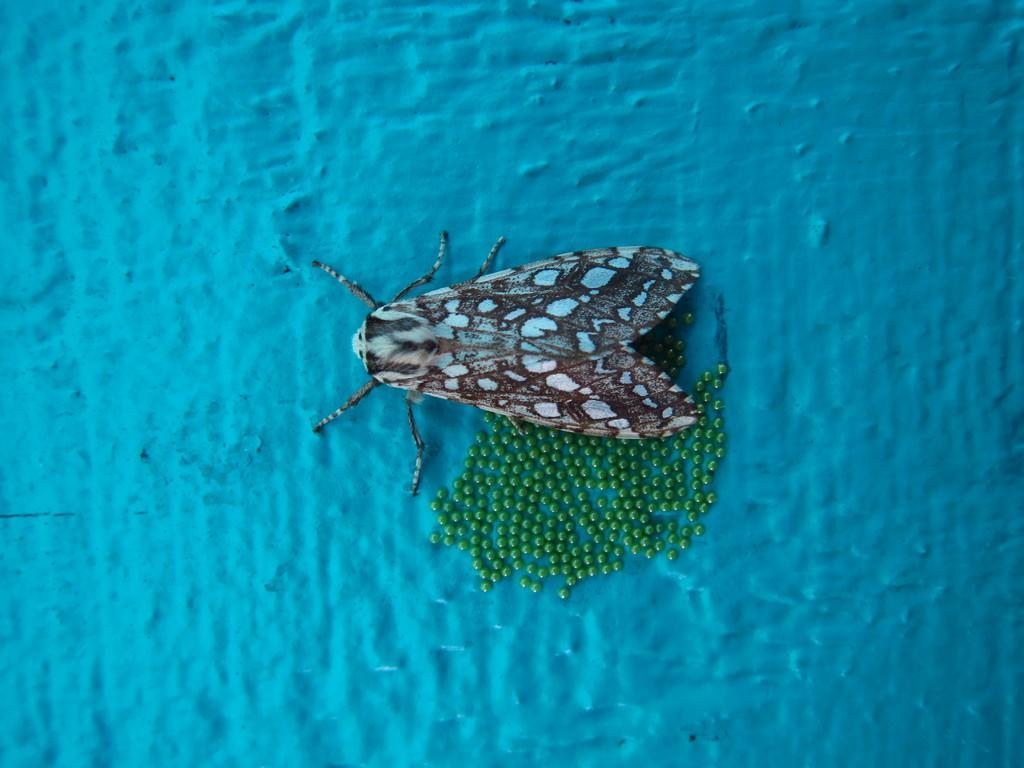What is the main subject of the image? The main subject of the image is an insect. Can you describe the insect's appearance? The insect has green color eggs on it. What color is the background of the image? The background of the image is blue in color. What month is it in the image? There is no indication of a specific month in the image, as it only features an insect with green color eggs and a blue background. Can you see any icicles in the image? There are no icicles present in the image. 